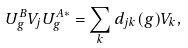<formula> <loc_0><loc_0><loc_500><loc_500>U _ { g } ^ { B } V _ { j } U _ { g } ^ { A \ast } = \sum _ { k } d _ { j k } ( g ) V _ { k } ,</formula> 